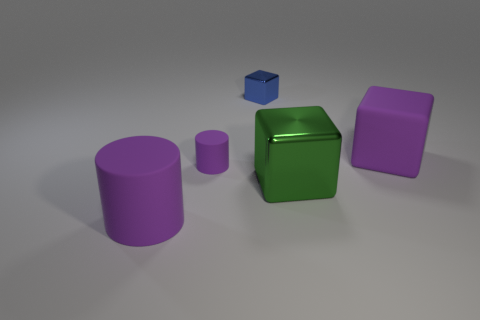How many rubber objects are the same color as the tiny cube?
Your answer should be compact. 0. How many things are either rubber objects left of the small blue thing or purple rubber things that are to the right of the tiny metal thing?
Keep it short and to the point. 3. There is a big object in front of the green shiny cube; how many large objects are in front of it?
Your answer should be very brief. 0. What is the color of the big cube that is made of the same material as the small purple cylinder?
Provide a succinct answer. Purple. Are there any yellow matte cubes of the same size as the blue block?
Your answer should be very brief. No. There is a object that is the same size as the blue block; what is its shape?
Your answer should be compact. Cylinder. Is there another large object that has the same shape as the green metallic thing?
Keep it short and to the point. Yes. Are the tiny purple cylinder and the large purple thing that is right of the blue object made of the same material?
Your answer should be very brief. Yes. Are there any other small cubes of the same color as the tiny cube?
Your response must be concise. No. What number of other things are there of the same material as the purple block
Ensure brevity in your answer.  2. 